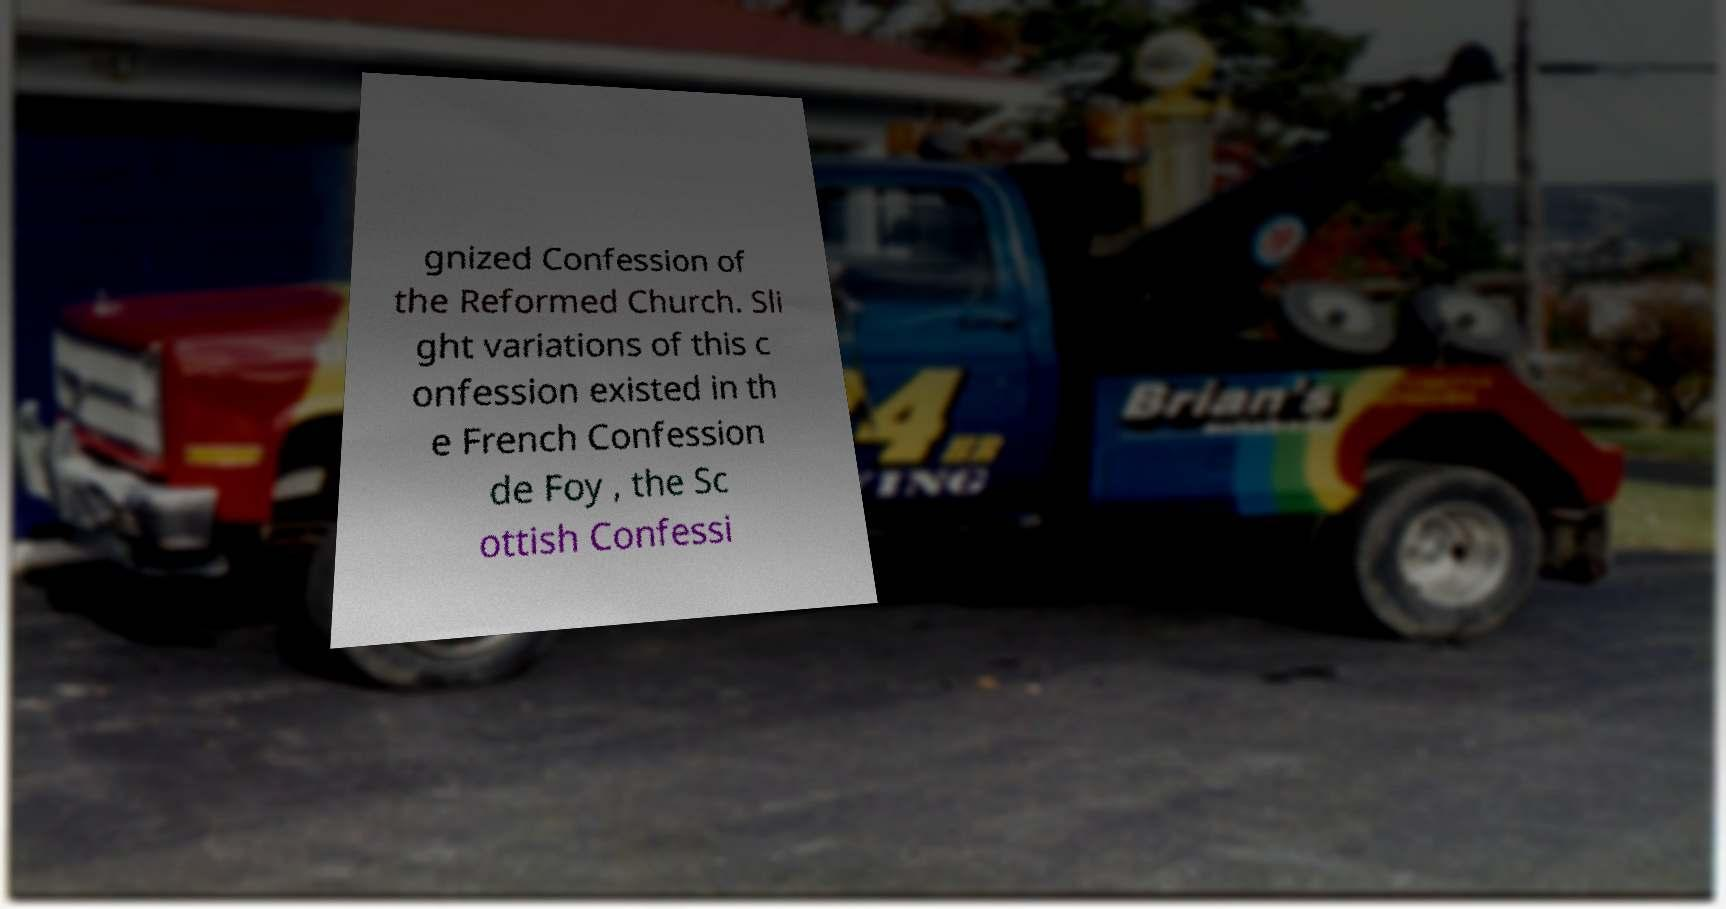Can you accurately transcribe the text from the provided image for me? gnized Confession of the Reformed Church. Sli ght variations of this c onfession existed in th e French Confession de Foy , the Sc ottish Confessi 